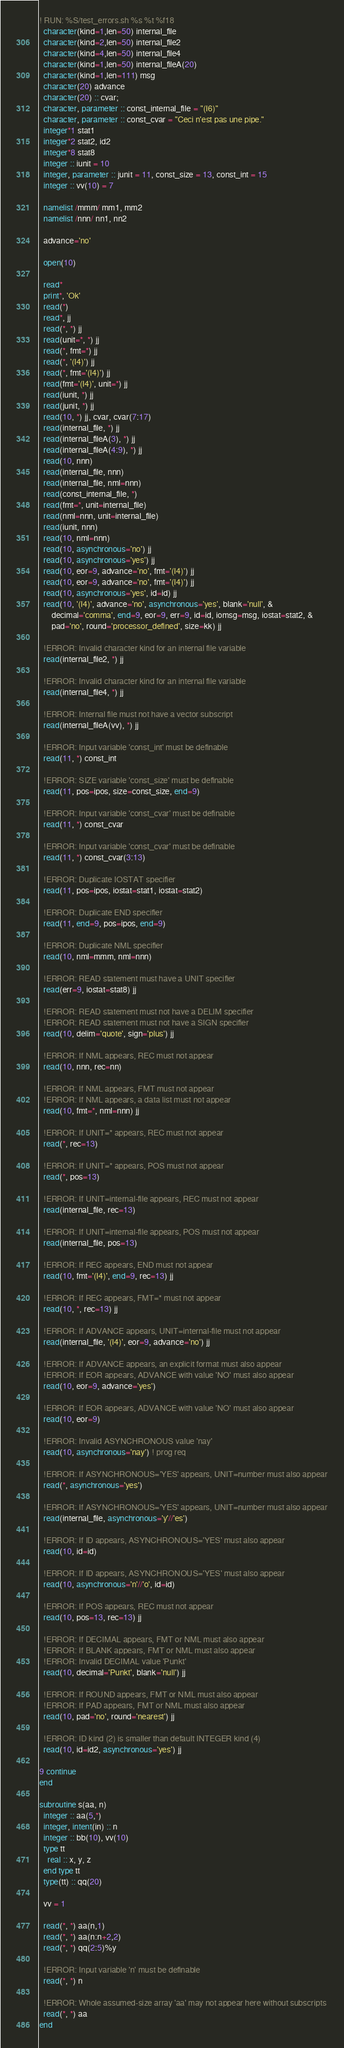<code> <loc_0><loc_0><loc_500><loc_500><_FORTRAN_>! RUN: %S/test_errors.sh %s %t %f18
  character(kind=1,len=50) internal_file
  character(kind=2,len=50) internal_file2
  character(kind=4,len=50) internal_file4
  character(kind=1,len=50) internal_fileA(20)
  character(kind=1,len=111) msg
  character(20) advance
  character(20) :: cvar;
  character, parameter :: const_internal_file = "(I6)"
  character, parameter :: const_cvar = "Ceci n'est pas une pipe."
  integer*1 stat1
  integer*2 stat2, id2
  integer*8 stat8
  integer :: iunit = 10
  integer, parameter :: junit = 11, const_size = 13, const_int = 15
  integer :: vv(10) = 7

  namelist /mmm/ mm1, mm2
  namelist /nnn/ nn1, nn2

  advance='no'

  open(10)

  read*
  print*, 'Ok'
  read(*)
  read*, jj
  read(*, *) jj
  read(unit=*, *) jj
  read(*, fmt=*) jj
  read(*, '(I4)') jj
  read(*, fmt='(I4)') jj
  read(fmt='(I4)', unit=*) jj
  read(iunit, *) jj
  read(junit, *) jj
  read(10, *) jj, cvar, cvar(7:17)
  read(internal_file, *) jj
  read(internal_fileA(3), *) jj
  read(internal_fileA(4:9), *) jj
  read(10, nnn)
  read(internal_file, nnn)
  read(internal_file, nml=nnn)
  read(const_internal_file, *)
  read(fmt=*, unit=internal_file)
  read(nml=nnn, unit=internal_file)
  read(iunit, nnn)
  read(10, nml=nnn)
  read(10, asynchronous='no') jj
  read(10, asynchronous='yes') jj
  read(10, eor=9, advance='no', fmt='(I4)') jj
  read(10, eor=9, advance='no', fmt='(I4)') jj
  read(10, asynchronous='yes', id=id) jj
  read(10, '(I4)', advance='no', asynchronous='yes', blank='null', &
      decimal='comma', end=9, eor=9, err=9, id=id, iomsg=msg, iostat=stat2, &
      pad='no', round='processor_defined', size=kk) jj

  !ERROR: Invalid character kind for an internal file variable
  read(internal_file2, *) jj

  !ERROR: Invalid character kind for an internal file variable
  read(internal_file4, *) jj

  !ERROR: Internal file must not have a vector subscript
  read(internal_fileA(vv), *) jj

  !ERROR: Input variable 'const_int' must be definable
  read(11, *) const_int

  !ERROR: SIZE variable 'const_size' must be definable
  read(11, pos=ipos, size=const_size, end=9)

  !ERROR: Input variable 'const_cvar' must be definable
  read(11, *) const_cvar

  !ERROR: Input variable 'const_cvar' must be definable
  read(11, *) const_cvar(3:13)

  !ERROR: Duplicate IOSTAT specifier
  read(11, pos=ipos, iostat=stat1, iostat=stat2)

  !ERROR: Duplicate END specifier
  read(11, end=9, pos=ipos, end=9)

  !ERROR: Duplicate NML specifier
  read(10, nml=mmm, nml=nnn)

  !ERROR: READ statement must have a UNIT specifier
  read(err=9, iostat=stat8) jj

  !ERROR: READ statement must not have a DELIM specifier
  !ERROR: READ statement must not have a SIGN specifier
  read(10, delim='quote', sign='plus') jj

  !ERROR: If NML appears, REC must not appear
  read(10, nnn, rec=nn)

  !ERROR: If NML appears, FMT must not appear
  !ERROR: If NML appears, a data list must not appear
  read(10, fmt=*, nml=nnn) jj

  !ERROR: If UNIT=* appears, REC must not appear
  read(*, rec=13)

  !ERROR: If UNIT=* appears, POS must not appear
  read(*, pos=13)

  !ERROR: If UNIT=internal-file appears, REC must not appear
  read(internal_file, rec=13)

  !ERROR: If UNIT=internal-file appears, POS must not appear
  read(internal_file, pos=13)

  !ERROR: If REC appears, END must not appear
  read(10, fmt='(I4)', end=9, rec=13) jj

  !ERROR: If REC appears, FMT=* must not appear
  read(10, *, rec=13) jj

  !ERROR: If ADVANCE appears, UNIT=internal-file must not appear
  read(internal_file, '(I4)', eor=9, advance='no') jj

  !ERROR: If ADVANCE appears, an explicit format must also appear
  !ERROR: If EOR appears, ADVANCE with value 'NO' must also appear
  read(10, eor=9, advance='yes')

  !ERROR: If EOR appears, ADVANCE with value 'NO' must also appear
  read(10, eor=9)

  !ERROR: Invalid ASYNCHRONOUS value 'nay'
  read(10, asynchronous='nay') ! prog req

  !ERROR: If ASYNCHRONOUS='YES' appears, UNIT=number must also appear
  read(*, asynchronous='yes')

  !ERROR: If ASYNCHRONOUS='YES' appears, UNIT=number must also appear
  read(internal_file, asynchronous='y'//'es')

  !ERROR: If ID appears, ASYNCHRONOUS='YES' must also appear
  read(10, id=id)

  !ERROR: If ID appears, ASYNCHRONOUS='YES' must also appear
  read(10, asynchronous='n'//'o', id=id)

  !ERROR: If POS appears, REC must not appear
  read(10, pos=13, rec=13) jj

  !ERROR: If DECIMAL appears, FMT or NML must also appear
  !ERROR: If BLANK appears, FMT or NML must also appear
  !ERROR: Invalid DECIMAL value 'Punkt'
  read(10, decimal='Punkt', blank='null') jj

  !ERROR: If ROUND appears, FMT or NML must also appear
  !ERROR: If PAD appears, FMT or NML must also appear
  read(10, pad='no', round='nearest') jj

  !ERROR: ID kind (2) is smaller than default INTEGER kind (4)
  read(10, id=id2, asynchronous='yes') jj

9 continue
end

subroutine s(aa, n)
  integer :: aa(5,*)
  integer, intent(in) :: n
  integer :: bb(10), vv(10)
  type tt
    real :: x, y, z
  end type tt
  type(tt) :: qq(20)

  vv = 1

  read(*, *) aa(n,1)
  read(*, *) aa(n:n+2,2)
  read(*, *) qq(2:5)%y

  !ERROR: Input variable 'n' must be definable
  read(*, *) n

  !ERROR: Whole assumed-size array 'aa' may not appear here without subscripts
  read(*, *) aa
end
</code> 